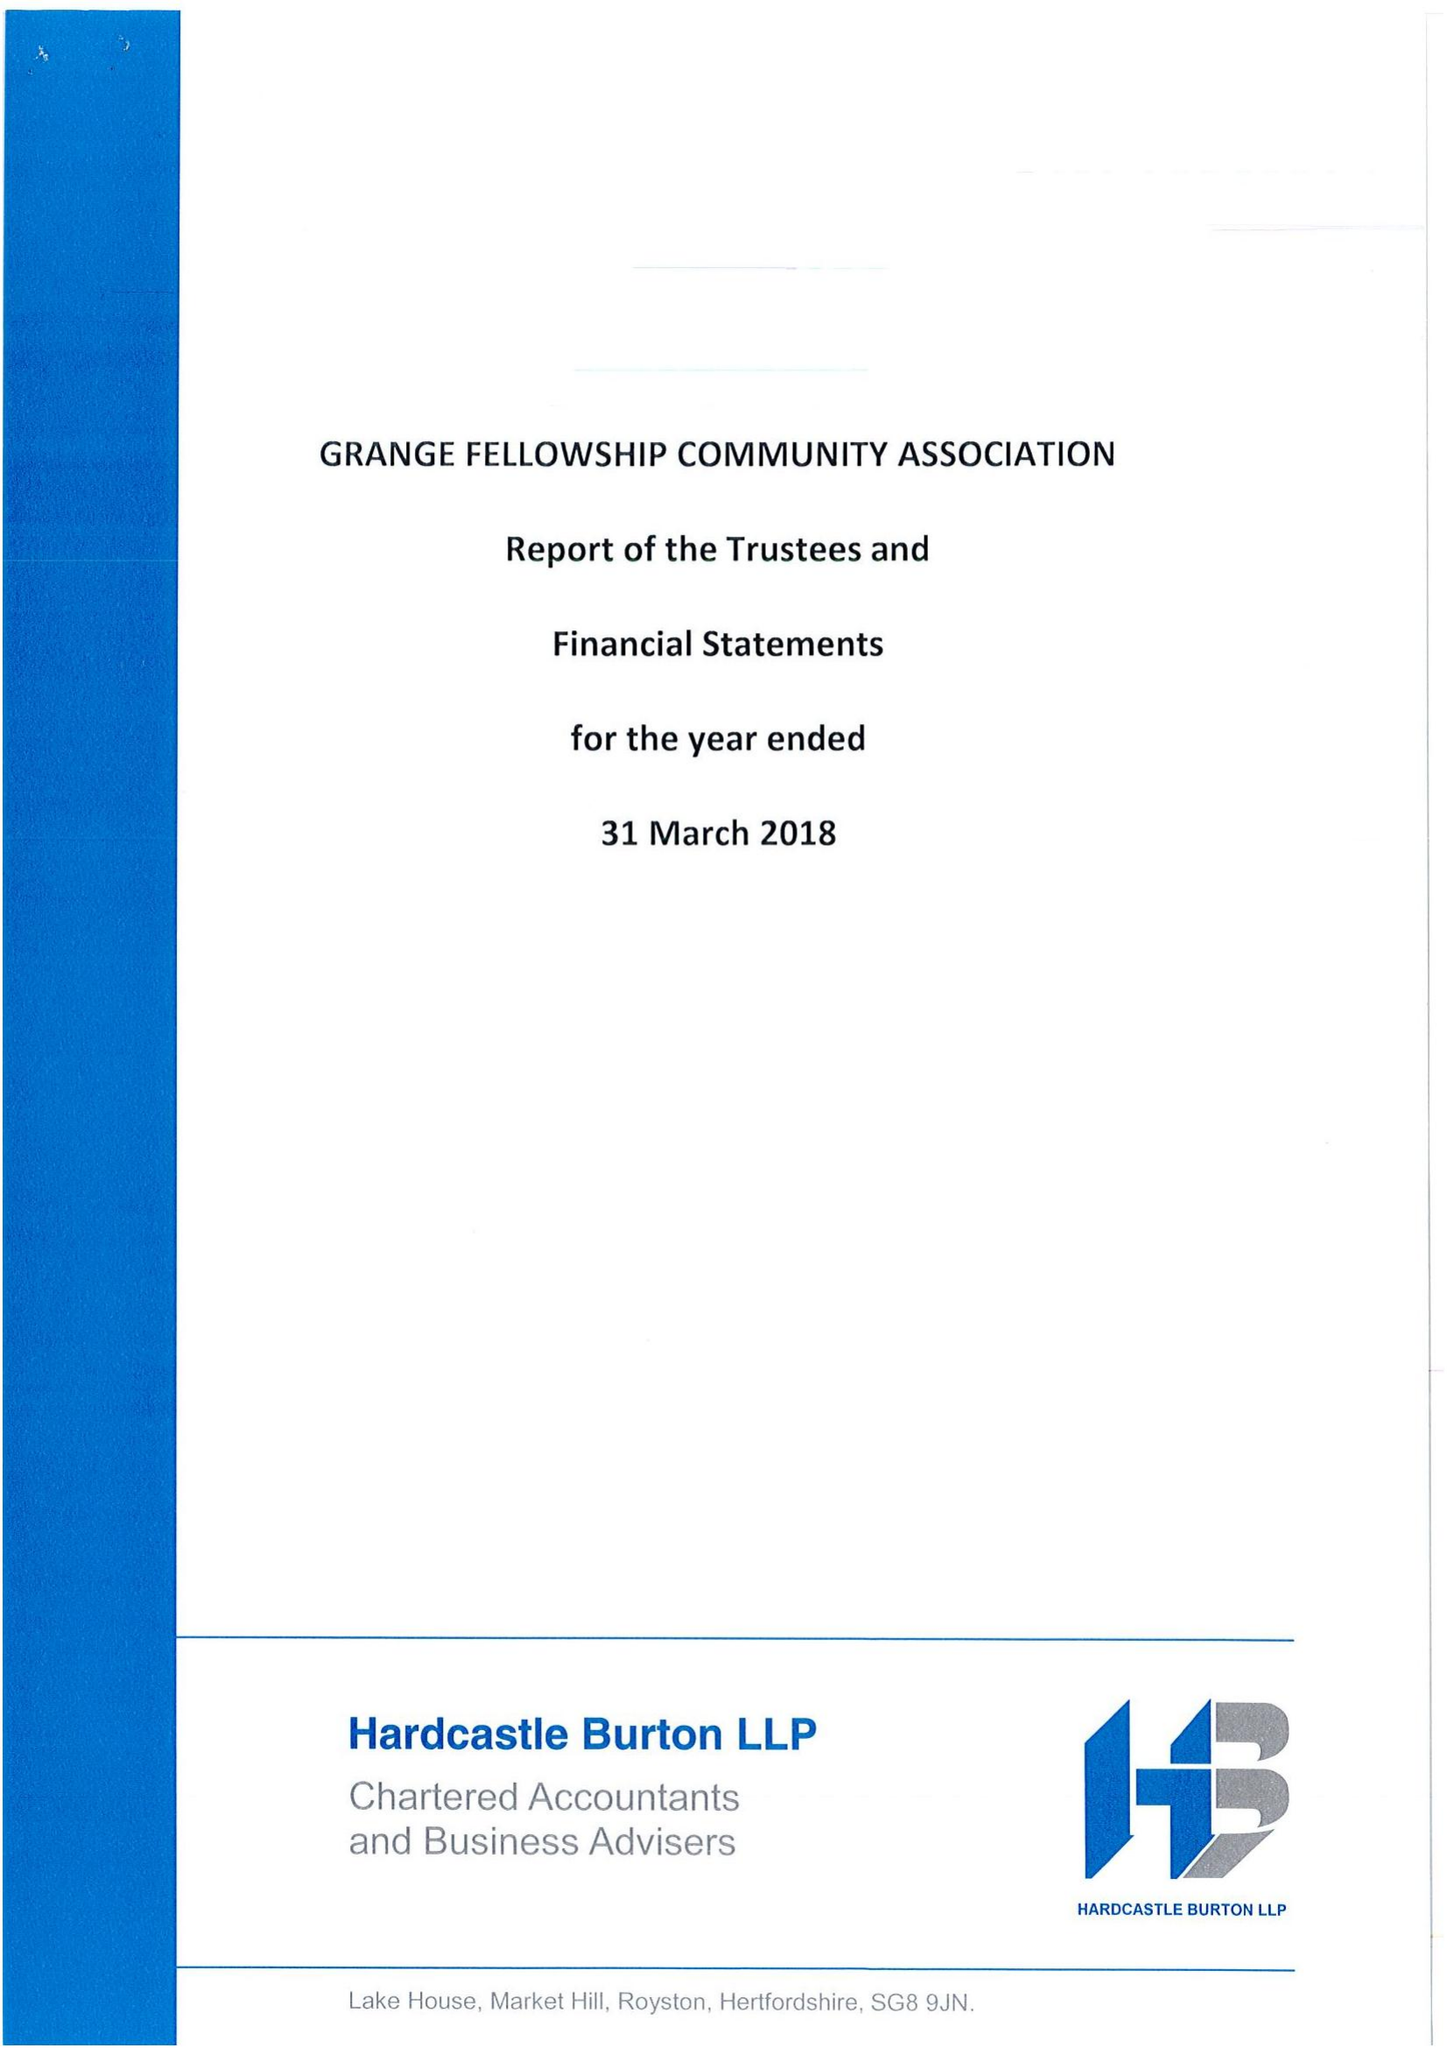What is the value for the spending_annually_in_british_pounds?
Answer the question using a single word or phrase. 456309.00 